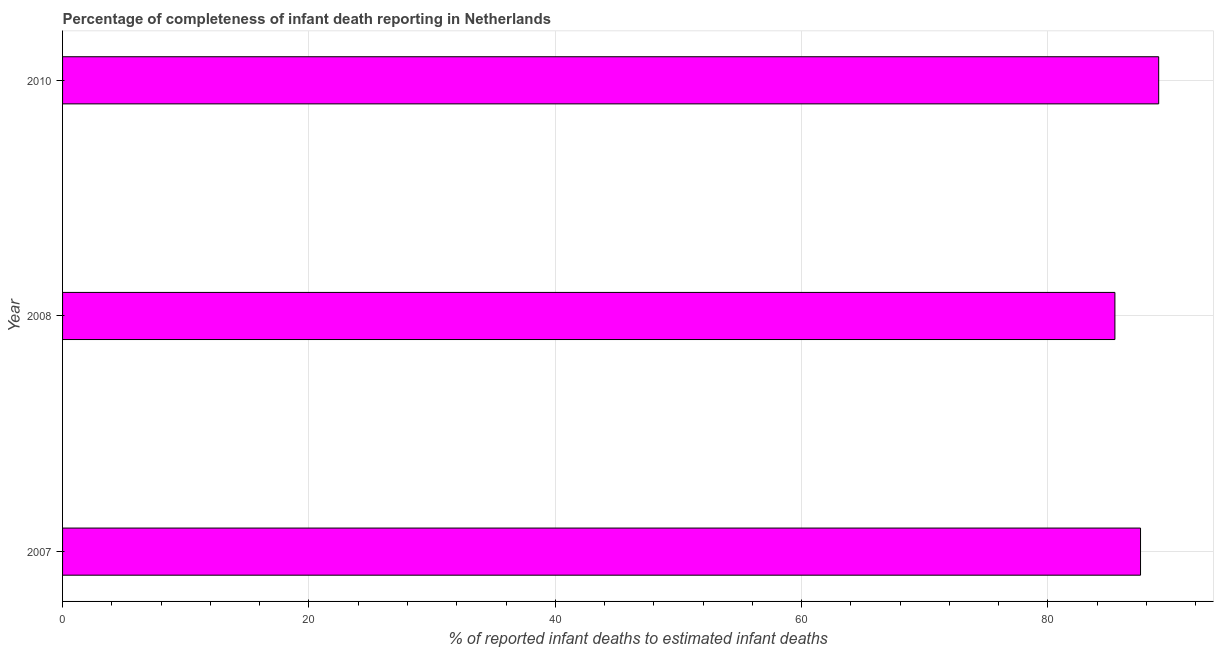Does the graph contain any zero values?
Give a very brief answer. No. What is the title of the graph?
Your answer should be compact. Percentage of completeness of infant death reporting in Netherlands. What is the label or title of the X-axis?
Make the answer very short. % of reported infant deaths to estimated infant deaths. What is the completeness of infant death reporting in 2007?
Make the answer very short. 87.51. Across all years, what is the maximum completeness of infant death reporting?
Keep it short and to the point. 88.99. Across all years, what is the minimum completeness of infant death reporting?
Keep it short and to the point. 85.43. In which year was the completeness of infant death reporting maximum?
Your answer should be very brief. 2010. What is the sum of the completeness of infant death reporting?
Keep it short and to the point. 261.94. What is the difference between the completeness of infant death reporting in 2007 and 2008?
Provide a succinct answer. 2.08. What is the average completeness of infant death reporting per year?
Ensure brevity in your answer.  87.31. What is the median completeness of infant death reporting?
Your response must be concise. 87.51. Do a majority of the years between 2008 and 2010 (inclusive) have completeness of infant death reporting greater than 60 %?
Make the answer very short. Yes. Is the difference between the completeness of infant death reporting in 2007 and 2008 greater than the difference between any two years?
Your response must be concise. No. What is the difference between the highest and the second highest completeness of infant death reporting?
Ensure brevity in your answer.  1.47. What is the difference between the highest and the lowest completeness of infant death reporting?
Your answer should be very brief. 3.55. How many bars are there?
Your response must be concise. 3. Are the values on the major ticks of X-axis written in scientific E-notation?
Give a very brief answer. No. What is the % of reported infant deaths to estimated infant deaths of 2007?
Your answer should be compact. 87.51. What is the % of reported infant deaths to estimated infant deaths in 2008?
Give a very brief answer. 85.43. What is the % of reported infant deaths to estimated infant deaths of 2010?
Your answer should be very brief. 88.99. What is the difference between the % of reported infant deaths to estimated infant deaths in 2007 and 2008?
Keep it short and to the point. 2.08. What is the difference between the % of reported infant deaths to estimated infant deaths in 2007 and 2010?
Give a very brief answer. -1.47. What is the difference between the % of reported infant deaths to estimated infant deaths in 2008 and 2010?
Ensure brevity in your answer.  -3.55. What is the ratio of the % of reported infant deaths to estimated infant deaths in 2007 to that in 2010?
Your answer should be very brief. 0.98. What is the ratio of the % of reported infant deaths to estimated infant deaths in 2008 to that in 2010?
Provide a succinct answer. 0.96. 